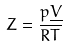Convert formula to latex. <formula><loc_0><loc_0><loc_500><loc_500>Z = \frac { p \underline { V } } { R T }</formula> 